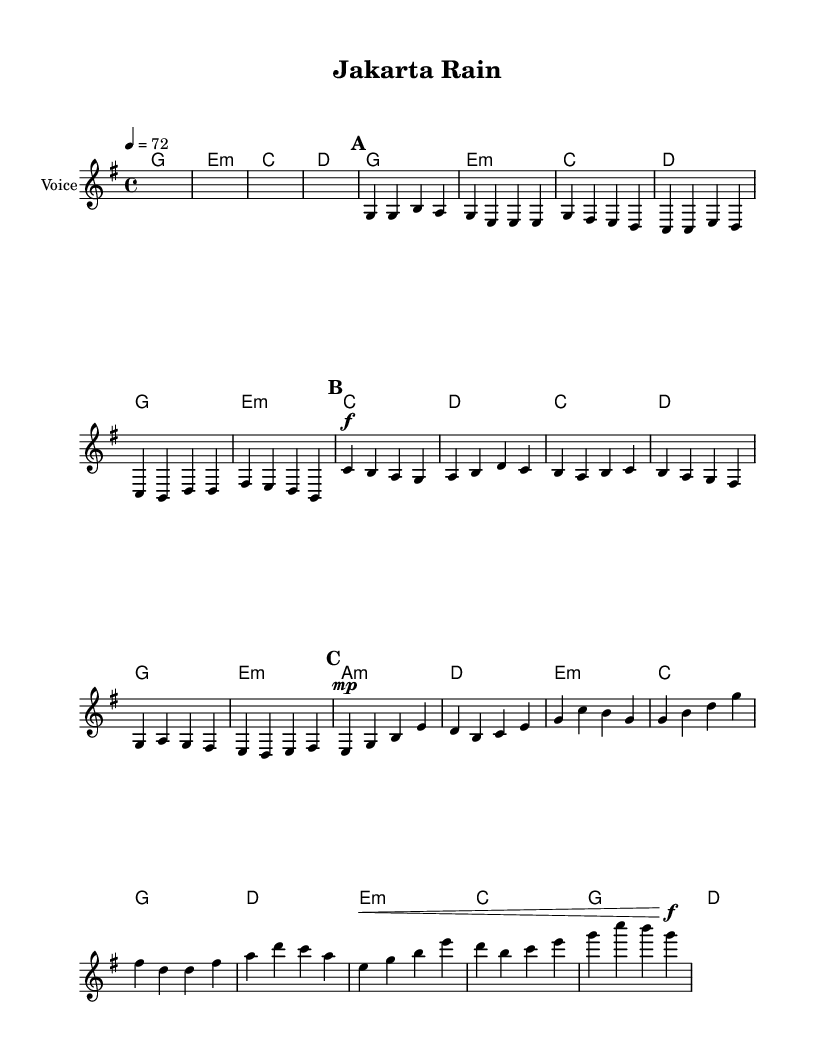What is the key signature of this music? The key signature is G major, which has one sharp (F#). This can be identified at the beginning of the score where the key signature is indicated, showing one sharp.
Answer: G major What is the time signature of this music? The time signature is 4/4, which is visible on the first line of the score, indicating that there are four beats per measure and the quarter note gets one beat.
Answer: 4/4 What is the tempo of this piece? The tempo is set at 72 beats per minute, which is stated at the beginning after the time signature. This means that there are 72 quarter-note beats in one minute.
Answer: 72 What type of song is "Jakarta Rain"? "Jakarta Rain" is an acoustic ballad, which is typically characterized by soft melodies and emotional lyrics often focused on themes of love and loss. The piece's structure, instrumentation, and content align with this genre.
Answer: Acoustic ballad How many sections does this song have? The song has three main sections: Verse 1, Chorus, and Bridge. Each section is separated distinctly in the score, allowing the performer to navigate through the song easily.
Answer: Three Which chord is used in the Chorus section? The chords used in the Chorus section include C, D, G, E minor, and A minor. These chords can be found detailed in the chord names written above the corresponding notes in that section.
Answer: C, D, G, E minor, A minor 